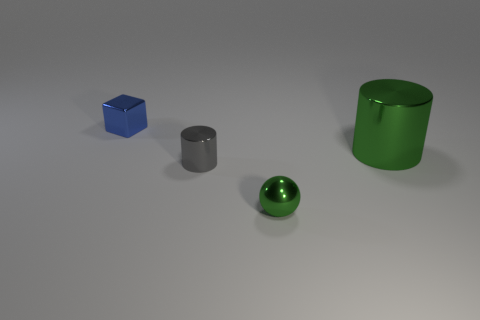Can you describe the shapes and colors of the objects presented in the image? Certainly! The image showcases four objects: a small blue cube, a silver cylinder that's medium in size, a smaller sphere with a shiny green surface, and a larger matte green cylinder. 